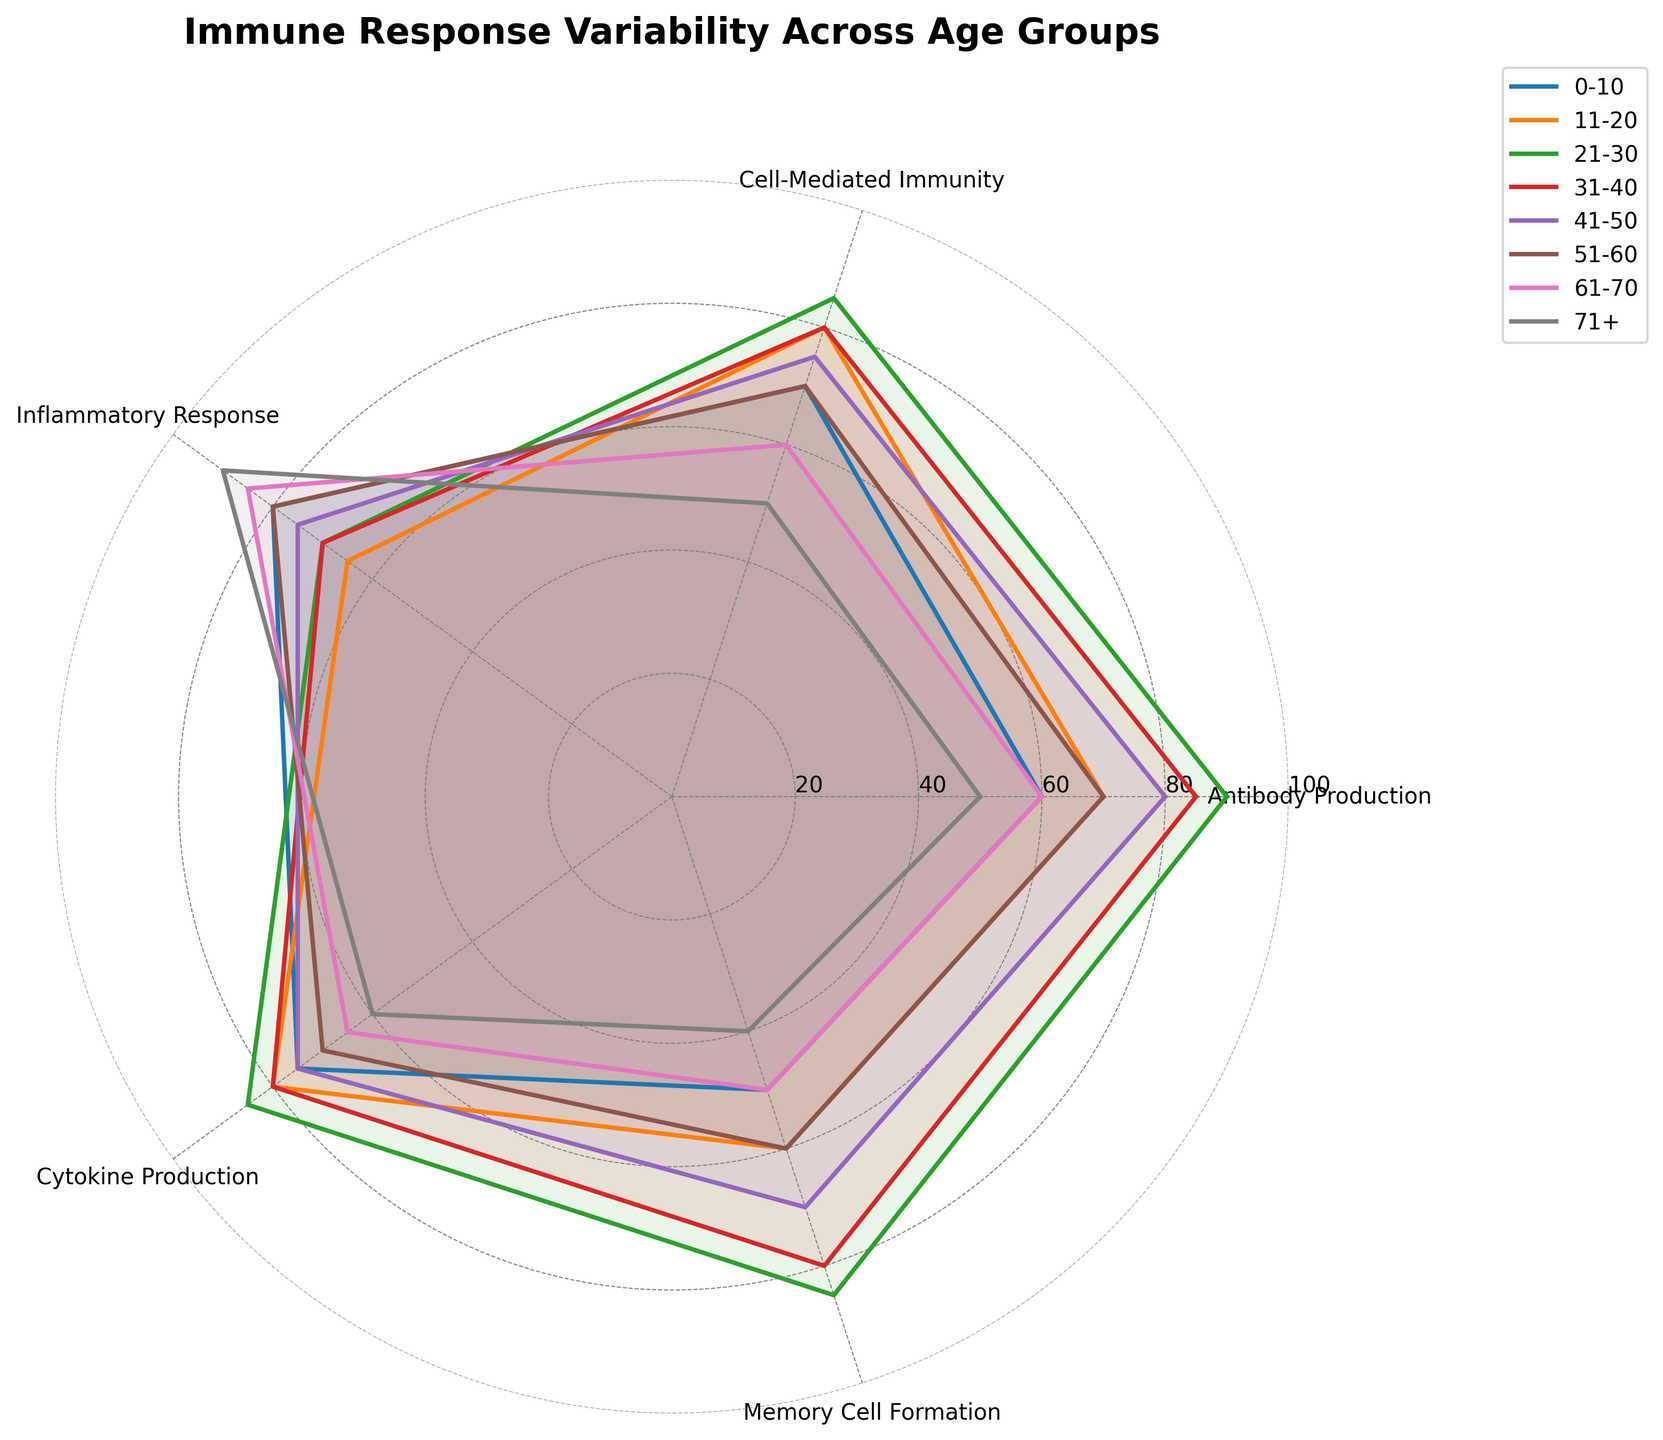what is the title of the figure? The title of the figure is displayed at the top of the radar chart. It is often written in a prominent font and highlights the main focus of the chart. In this case, the title is "Immune Response Variability Across Age Groups".
Answer: Immune Response Variability Across Age Groups Which age group has the highest antibody production? To find the highest antibody production, look at the "Antibody Production" axis and see which plot reaches the farthest along this axis. The age group 21-30 reaches the 90 mark, which is the highest.
Answer: 21-30 For the age group 31-40, what is the Inflammatory Response value, and how does it compare to the Cytokine Production value? Locate the age group 31-40 on the chart and trace the values for "Inflammatory Response" and "Cytokine Production". Inflammatory Response is 70, and Cytokine Production is 80. Compare these two values.
Answer: Inflammatory Response: 70, Cytokine Production: 80, lower Which age group shows the greatest variability in their immune response indicators? Variability can be assessed by the spread of the values along the axes. The age group 71+ has the widest range of values (from 40 for Memory Cell Formation to 90 for Inflammatory Response), indicating the greatest variability.
Answer: 71+ What is the average value of Cytokine Production across all age groups? Average is calculated by summing up all the values of Cytokine Production and dividing by the number of age groups. The values are 75, 80, 85, 80, 75, 70, 65, and 60. Sum = 590, and 590/8 = 73.75
Answer: 73.75 Which immune response indicator consistently shows a decline with increasing age? Track the values of each immune response indicator across the age groups in a sequential manner. Notice that "Memory Cell Formation" generally shows a decline from 0-10 (50) to 71+ (40).
Answer: Memory Cell Formation What are the radial axis labels, and what range do they span? The radial axis labels are typically displayed as concentric circles around the center point, indicating measurement levels. The labels here are 20, 40, 60, 80, and 100, and the range spans from 0 to 100.
Answer: 20, 40, 60, 80, 100 How do the Antibody Production values for the age groups 11-20 and 51-60 compare? Locate the values for Antibody Production for both age groups. For 11-20 it is 70, and for 51-60 it is also 70. Both values are the same, so they are equal.
Answer: Equal 